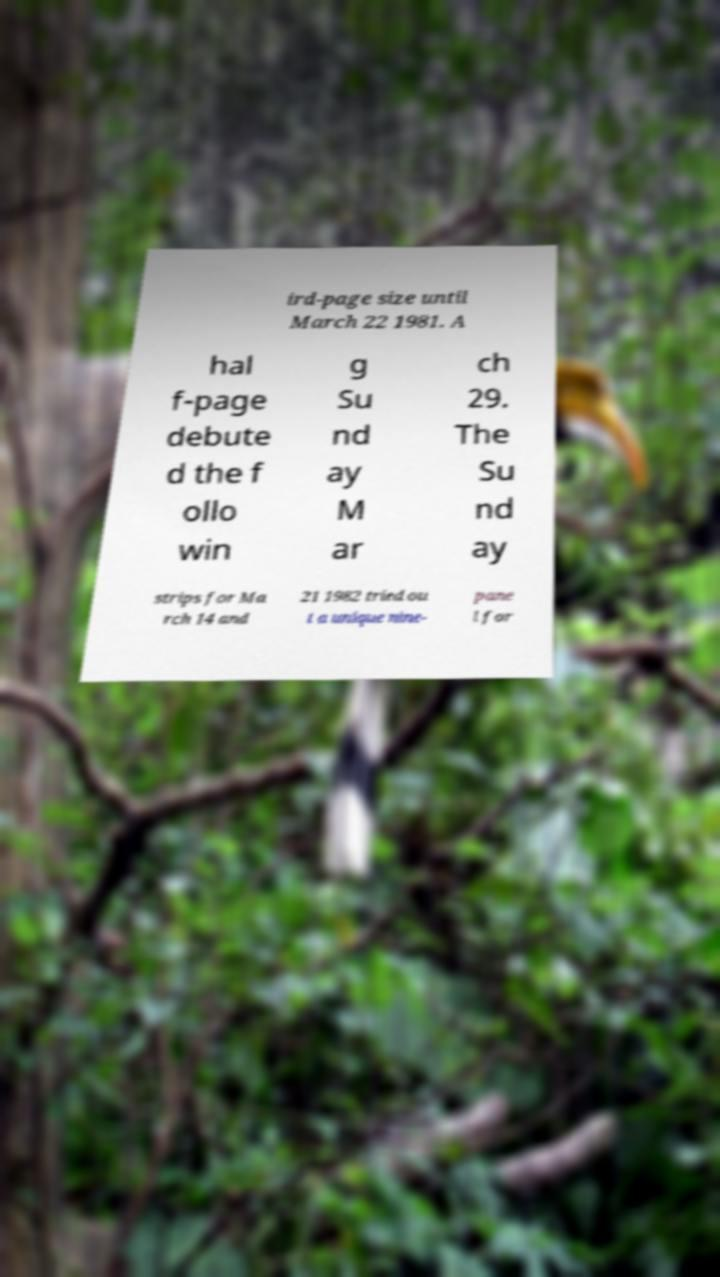Could you extract and type out the text from this image? ird-page size until March 22 1981. A hal f-page debute d the f ollo win g Su nd ay M ar ch 29. The Su nd ay strips for Ma rch 14 and 21 1982 tried ou t a unique nine- pane l for 